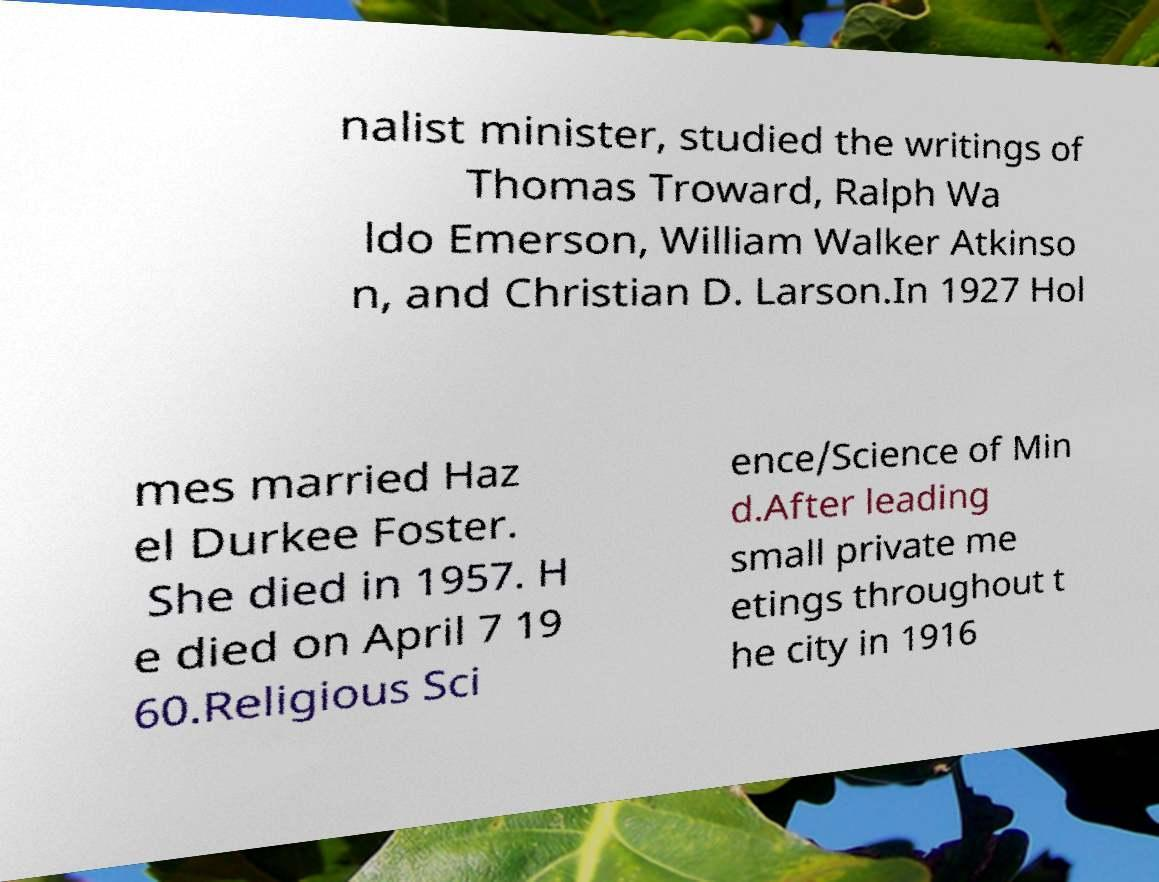Can you read and provide the text displayed in the image?This photo seems to have some interesting text. Can you extract and type it out for me? nalist minister, studied the writings of Thomas Troward, Ralph Wa ldo Emerson, William Walker Atkinso n, and Christian D. Larson.In 1927 Hol mes married Haz el Durkee Foster. She died in 1957. H e died on April 7 19 60.Religious Sci ence/Science of Min d.After leading small private me etings throughout t he city in 1916 